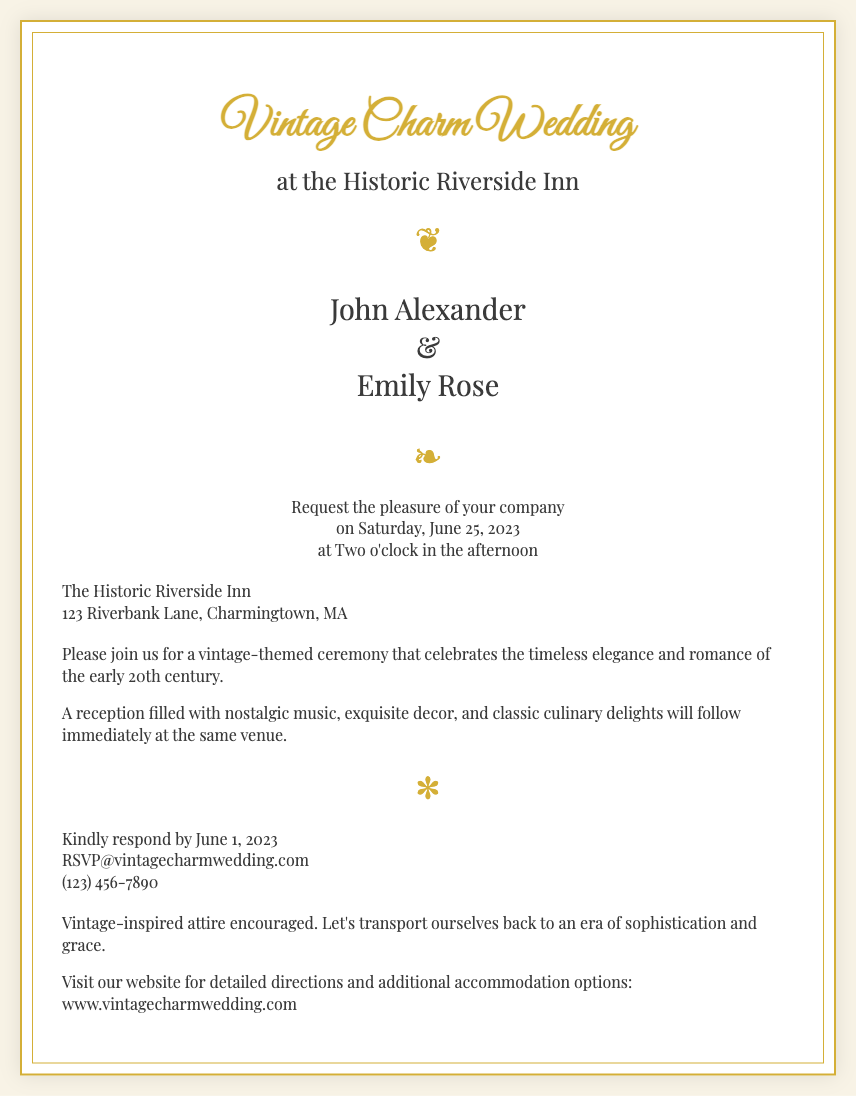What is the couple's name? The couple's names are specifically mentioned in the invitation, which are John Alexander and Emily Rose.
Answer: John Alexander and Emily Rose When is the wedding ceremony? The date and time for the wedding ceremony are stated in the invitation as Saturday, June 25, 2023, at Two o'clock in the afternoon.
Answer: Saturday, June 25, 2023 Where will the wedding take place? The location of the wedding is explicitly provided in the document as The Historic Riverside Inn, 123 Riverbank Lane, Charmingtown, MA.
Answer: The Historic Riverside Inn What theme is the wedding inspired by? The event is described to celebrate the timeless elegance and romance of the early 20th century, which indicates a vintage theme.
Answer: Vintage What should guests wear? The document states that vintage-inspired attire is encouraged for the event, hinting at a specific dress code for the guests.
Answer: Vintage-inspired attire When is the RSVP deadline? The deadline for RSVPs is mentioned as June 1, 2023, indicating when responses should be sent by.
Answer: June 1, 2023 What type of reception will follow the ceremony? The invitation outlines that there will be a reception filled with nostalgic music, exquisite decor, and classic culinary delights after the ceremony.
Answer: Nostalgic music, exquisite decor, classic culinary delights What is the contact method for RSVP? The invitation provides an email and phone number for RSVPs, which are RSVP@vintagecharmwedding.com and (123) 456-7890.
Answer: RSVP@vintagecharmwedding.com, (123) 456-7890 